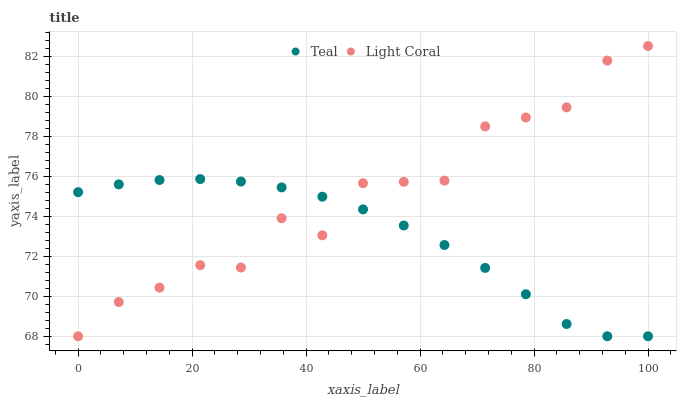Does Teal have the minimum area under the curve?
Answer yes or no. Yes. Does Light Coral have the maximum area under the curve?
Answer yes or no. Yes. Does Teal have the maximum area under the curve?
Answer yes or no. No. Is Teal the smoothest?
Answer yes or no. Yes. Is Light Coral the roughest?
Answer yes or no. Yes. Is Teal the roughest?
Answer yes or no. No. Does Light Coral have the lowest value?
Answer yes or no. Yes. Does Light Coral have the highest value?
Answer yes or no. Yes. Does Teal have the highest value?
Answer yes or no. No. Does Teal intersect Light Coral?
Answer yes or no. Yes. Is Teal less than Light Coral?
Answer yes or no. No. Is Teal greater than Light Coral?
Answer yes or no. No. 